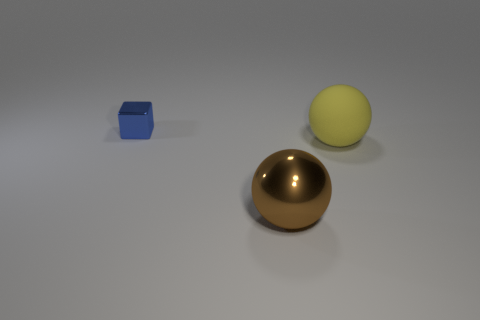Is there any other thing that is the same size as the shiny cube?
Your answer should be very brief. No. Are there the same number of big yellow objects that are in front of the brown metal sphere and yellow matte balls behind the large yellow rubber sphere?
Offer a very short reply. Yes. Are there any other things that have the same material as the yellow ball?
Provide a succinct answer. No. There is a brown sphere; is its size the same as the object right of the large metallic thing?
Make the answer very short. Yes. What is the material of the sphere that is right of the metal object that is in front of the big matte object?
Provide a short and direct response. Rubber. Is the number of small blue shiny things that are on the right side of the large metallic sphere the same as the number of big cyan rubber cylinders?
Your answer should be compact. Yes. There is a object that is both behind the brown thing and to the left of the yellow object; how big is it?
Offer a terse response. Small. The sphere that is left of the ball that is behind the big brown metallic sphere is what color?
Keep it short and to the point. Brown. How many brown things are either small metal cylinders or matte spheres?
Your answer should be very brief. 0. There is a thing that is both behind the big brown object and to the right of the small blue object; what is its color?
Ensure brevity in your answer.  Yellow. 